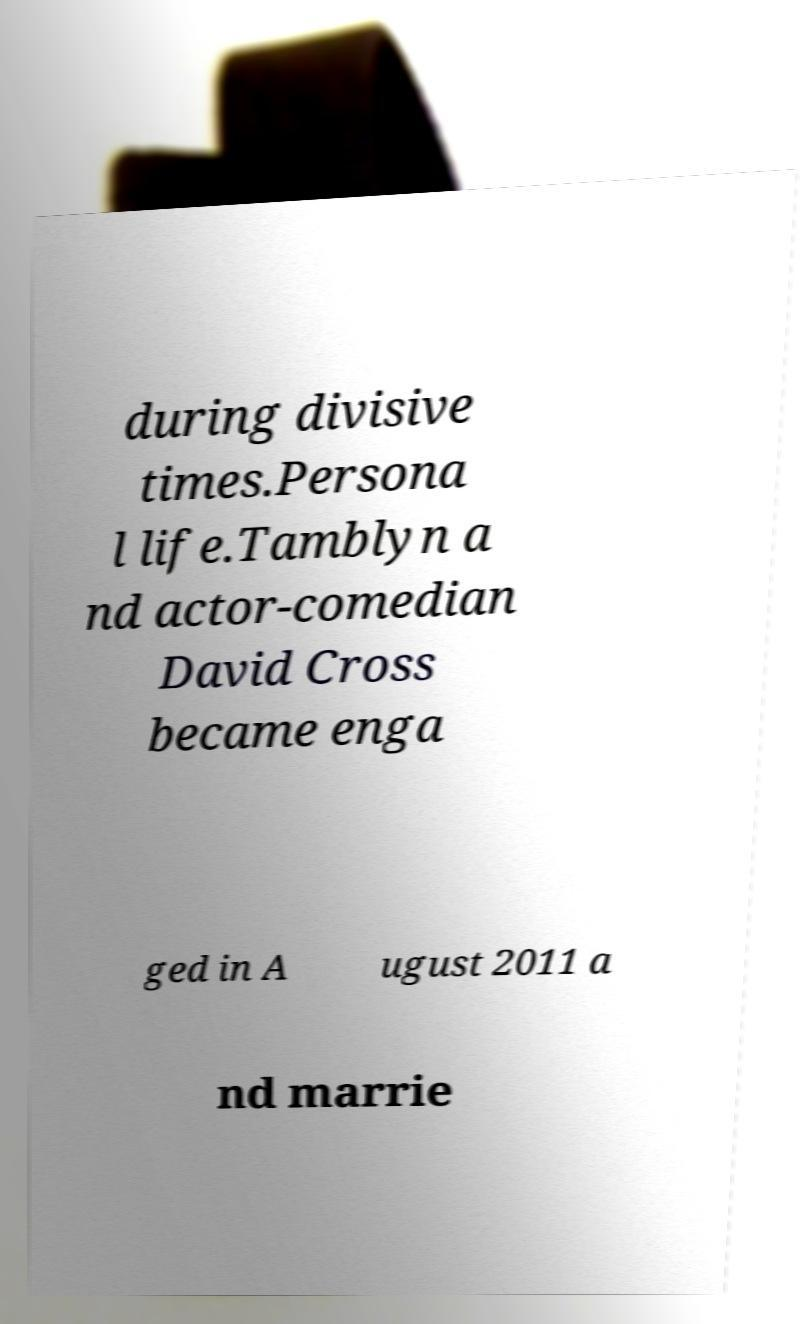Could you extract and type out the text from this image? during divisive times.Persona l life.Tamblyn a nd actor-comedian David Cross became enga ged in A ugust 2011 a nd marrie 